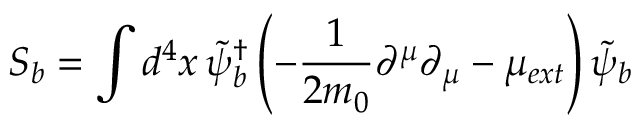Convert formula to latex. <formula><loc_0><loc_0><loc_500><loc_500>S _ { b } = \int d ^ { 4 } x \, \widetilde { \psi } _ { b } ^ { \dagger } \left ( - \frac { 1 } { 2 m _ { 0 } } \partial ^ { \mu } \partial _ { \mu } - \mu _ { e x t } \right ) \widetilde { \psi } _ { b }</formula> 